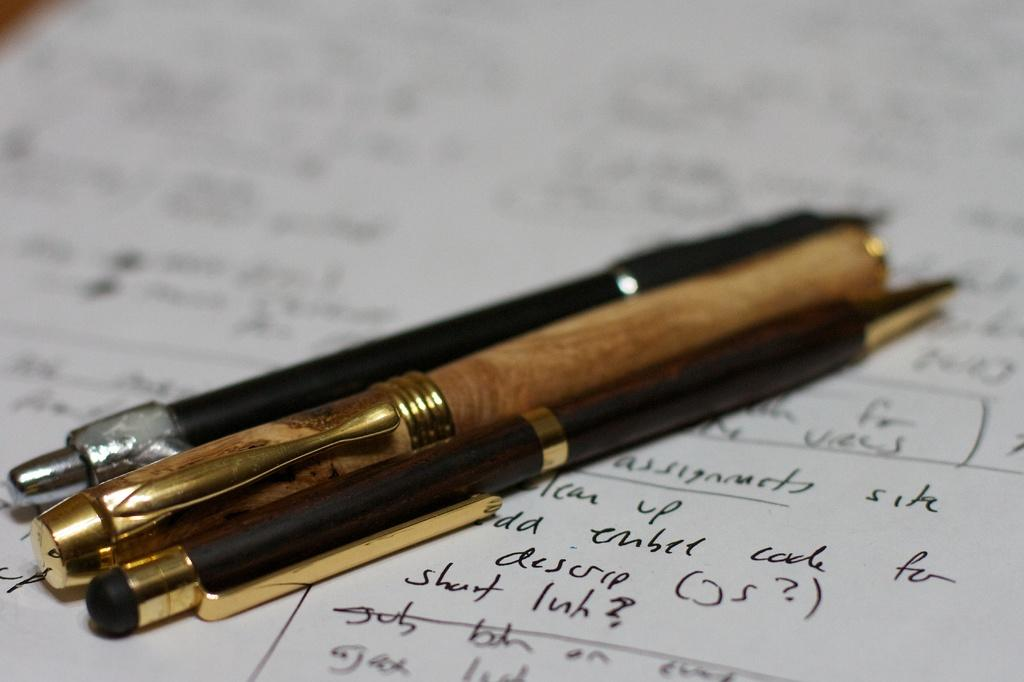<image>
Provide a brief description of the given image. 3 pens laying a piece of paper with writing, one of the words is ember. 